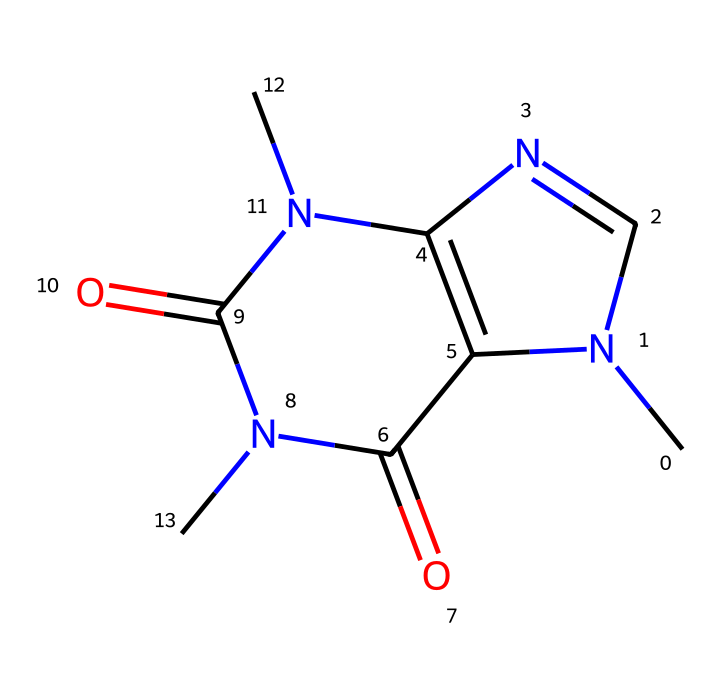What is the molecular formula of caffeine? By analyzing the structure represented by the SMILES notation, we can count the number of each type of atom present. The caffeine molecule includes 8 carbon atoms (C), 10 hydrogen atoms (H), 4 nitrogen atoms (N), and 2 oxygen atoms (O). Therefore, the molecular formula is C8H10N4O2.
Answer: C8H10N4O2 How many nitrogen atoms are in caffeine? The SMILES representation shows that there are 4 nitrogen atoms (N) present in the structure of caffeine. This can be confirmed by counting the nitrogen symbols within the chemical structure.
Answer: 4 Is caffeine an aromatic compound? To determine if caffeine is aromatic, we look for benzene-like rings in its structure that follow Huckel's rule (4n + 2 π electrons). Caffeine does not contain such structures and instead has a combination of nitrogen and carbon in a piperidine-like ring, confirming it is not aromatic.
Answer: No What type of functional groups are present in caffeine? Caffeine contains amide functional groups, which can be identified by the presence of carbonyl groups (C=O) bonded to nitrogen atoms (N) within the structure. This means that the amide functional group's characteristics contribute to the entirety of caffeine's molecular structure.
Answer: Amide Which part of the caffeine structure contributes to its stimulant effect? The presence of three nitrogen atoms in the structure is crucial as they are part of the methylxanthine structure, which is known for its stimulant properties. This interaction with adenosine receptors in the brain primarily leads to its stimulating effects.
Answer: Nitrogen atoms 